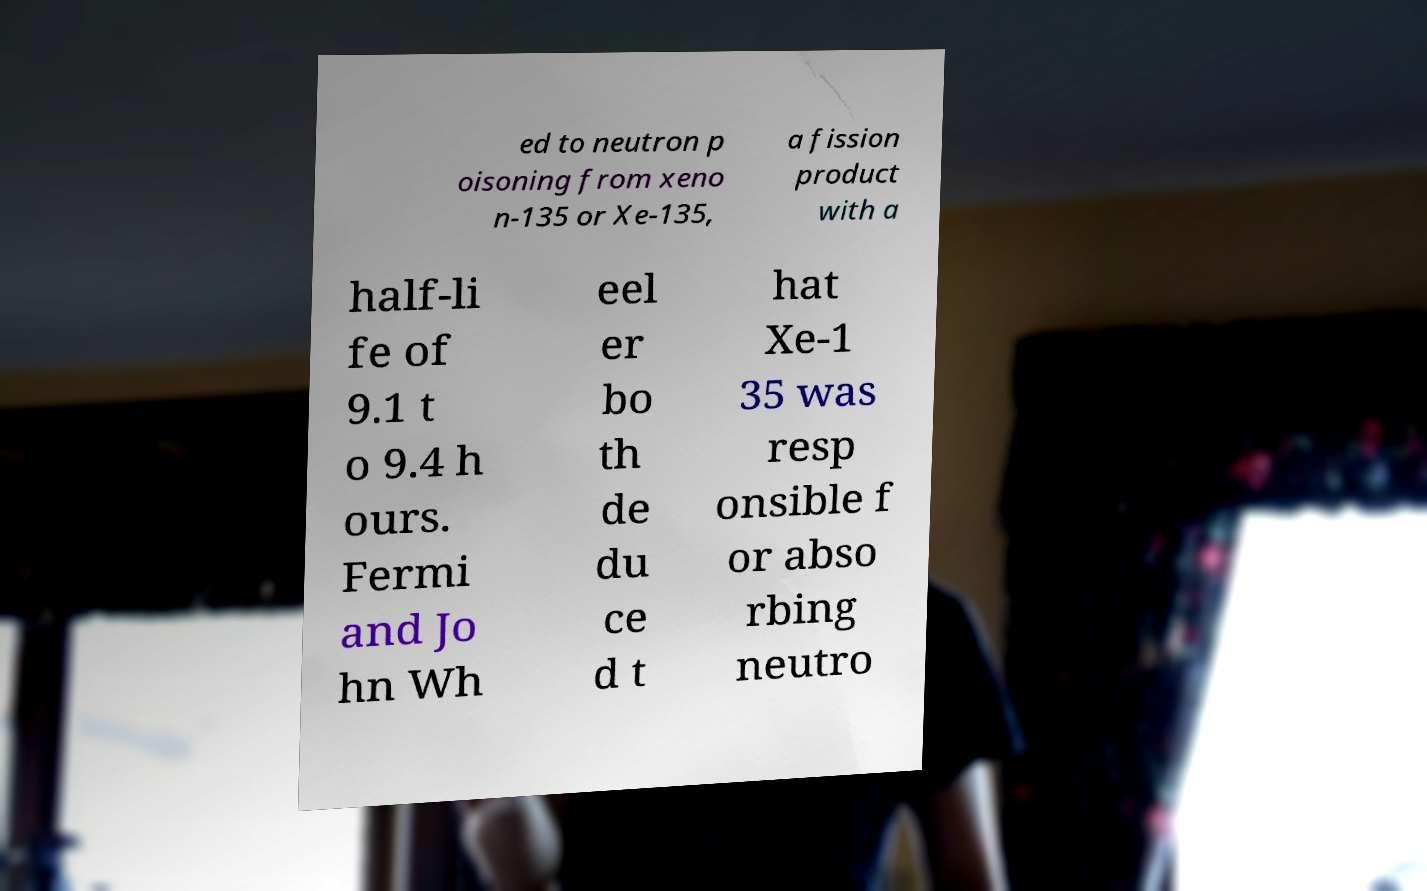I need the written content from this picture converted into text. Can you do that? ed to neutron p oisoning from xeno n-135 or Xe-135, a fission product with a half-li fe of 9.1 t o 9.4 h ours. Fermi and Jo hn Wh eel er bo th de du ce d t hat Xe-1 35 was resp onsible f or abso rbing neutro 